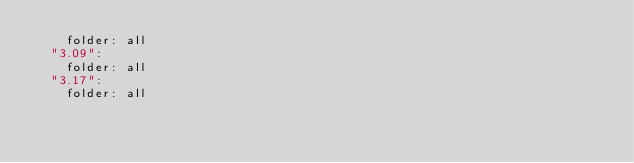<code> <loc_0><loc_0><loc_500><loc_500><_YAML_>    folder: all
  "3.09":
    folder: all
  "3.17":
    folder: all
</code> 